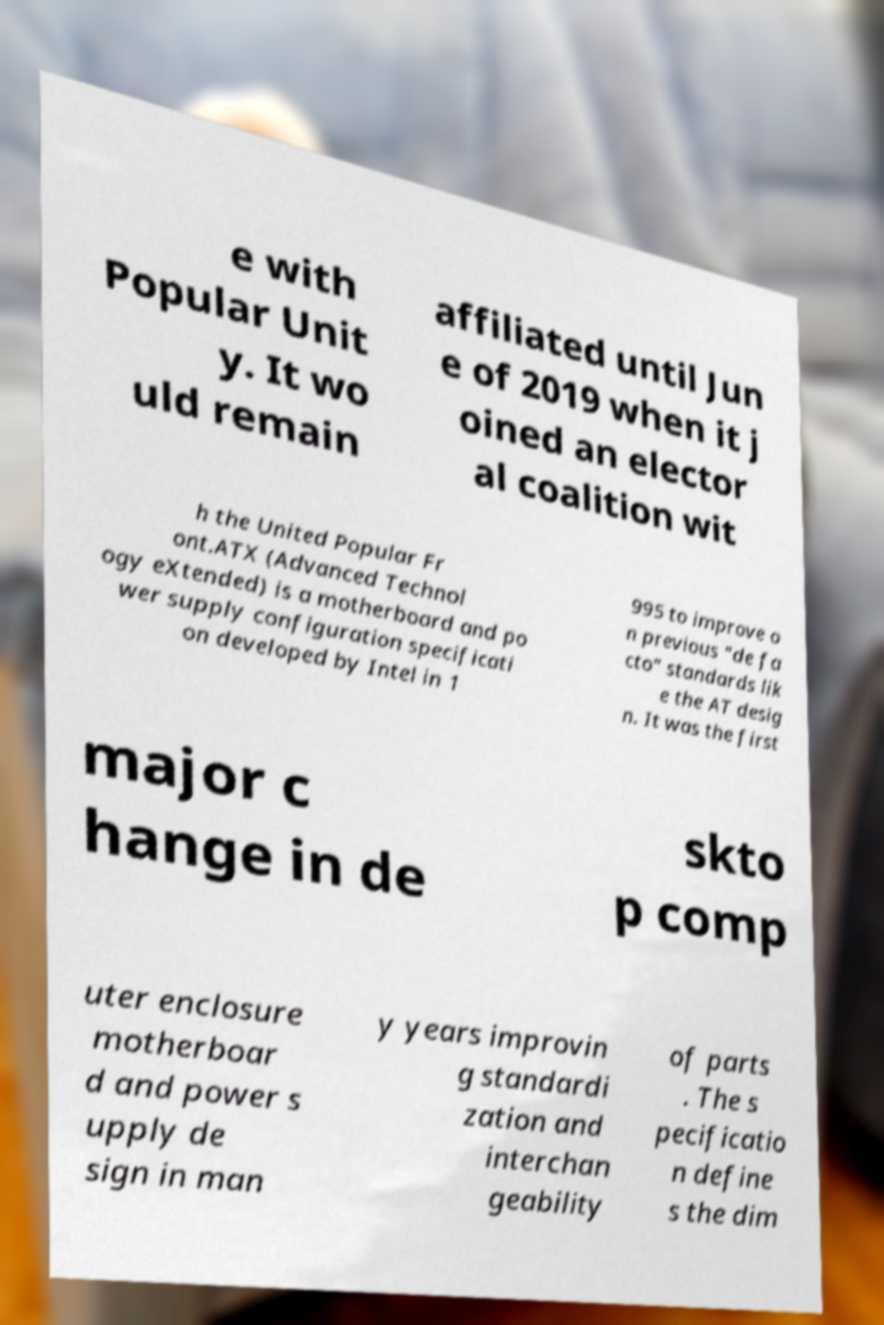What messages or text are displayed in this image? I need them in a readable, typed format. e with Popular Unit y. It wo uld remain affiliated until Jun e of 2019 when it j oined an elector al coalition wit h the United Popular Fr ont.ATX (Advanced Technol ogy eXtended) is a motherboard and po wer supply configuration specificati on developed by Intel in 1 995 to improve o n previous "de fa cto" standards lik e the AT desig n. It was the first major c hange in de skto p comp uter enclosure motherboar d and power s upply de sign in man y years improvin g standardi zation and interchan geability of parts . The s pecificatio n define s the dim 